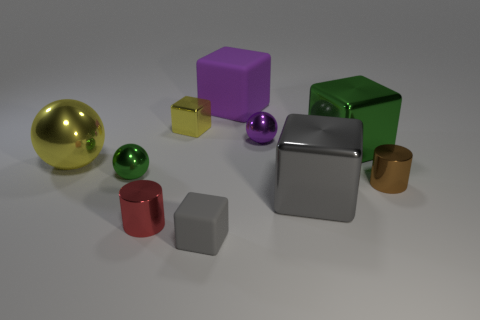There is a brown thing that is the same size as the purple ball; what shape is it? cylinder 